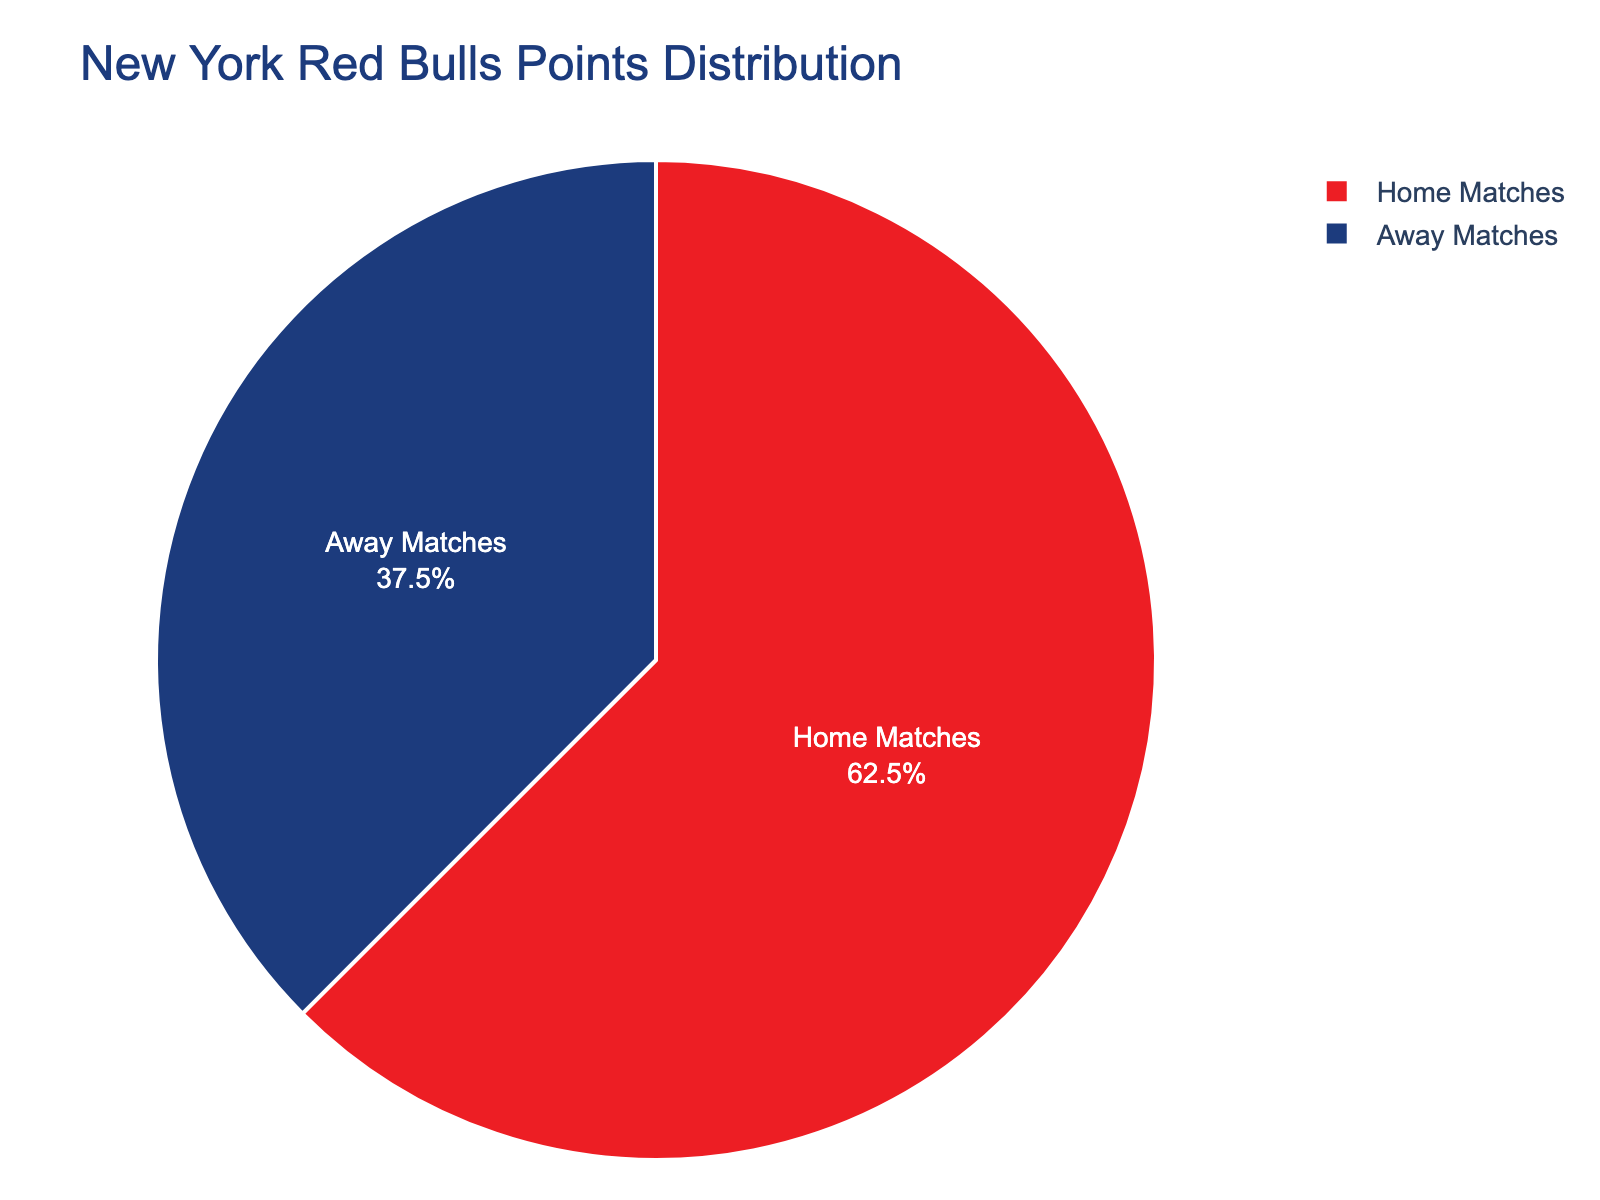What's the percentage breakdown of points earned from home and away matches? The pie chart shows Home Matches contributing 62.5% and Away Matches contributing 37.5% to the total points.
Answer: Home: 62.5%, Away: 37.5% Which type of match contributed more points to the New York Red Bulls' total points? The slice representing Home Matches is larger than the one for Away Matches.
Answer: Home Matches What is the difference in percentage between points earned from home and away matches? Home Matches account for 62.5%, and Away Matches account for 37.5%. The difference is 62.5% - 37.5% = 25%.
Answer: 25% If the Red Bulls earned 40 points from away matches, how many points did they earn from home matches? Let X be the total points. Since away points are 37.5% of the total: 0.375X = 40, so X = 40/0.375 = 106.67. Home points = 62.5% of 106.67 = 0.625 * 106.67 ≈ 66.67.
Answer: 66.67 points What proportion of the total points were earned from matches played away? According to the pie chart, Away Matches contribute 37.5% of the total points.
Answer: 37.5% Is the contribution from home matches more than double that from away matches? The percentage from home matches is 62.5%, and from away matches is 37.5%. Doubling 37.5% gives 75%, which is more than 62.5%.
Answer: No What does the smaller slice of the pie chart represent? The smaller slice, which is 37.5%, represents Away Matches.
Answer: Away Matches How can you visually differentiate between points earned from home and away matches? The pie chart uses different colors for Home Matches and Away Matches, with Home Matches in red and Away Matches in blue.
Answer: By color: red for Home Matches, blue for Away Matches What is the ratio of points earned from home matches to those earned from away matches? The percentages are Home: 62.5%, Away: 37.5%. The ratio is 62.5/37.5 = 5/3 or approximately 1.67.
Answer: 5:3 or 1.67 